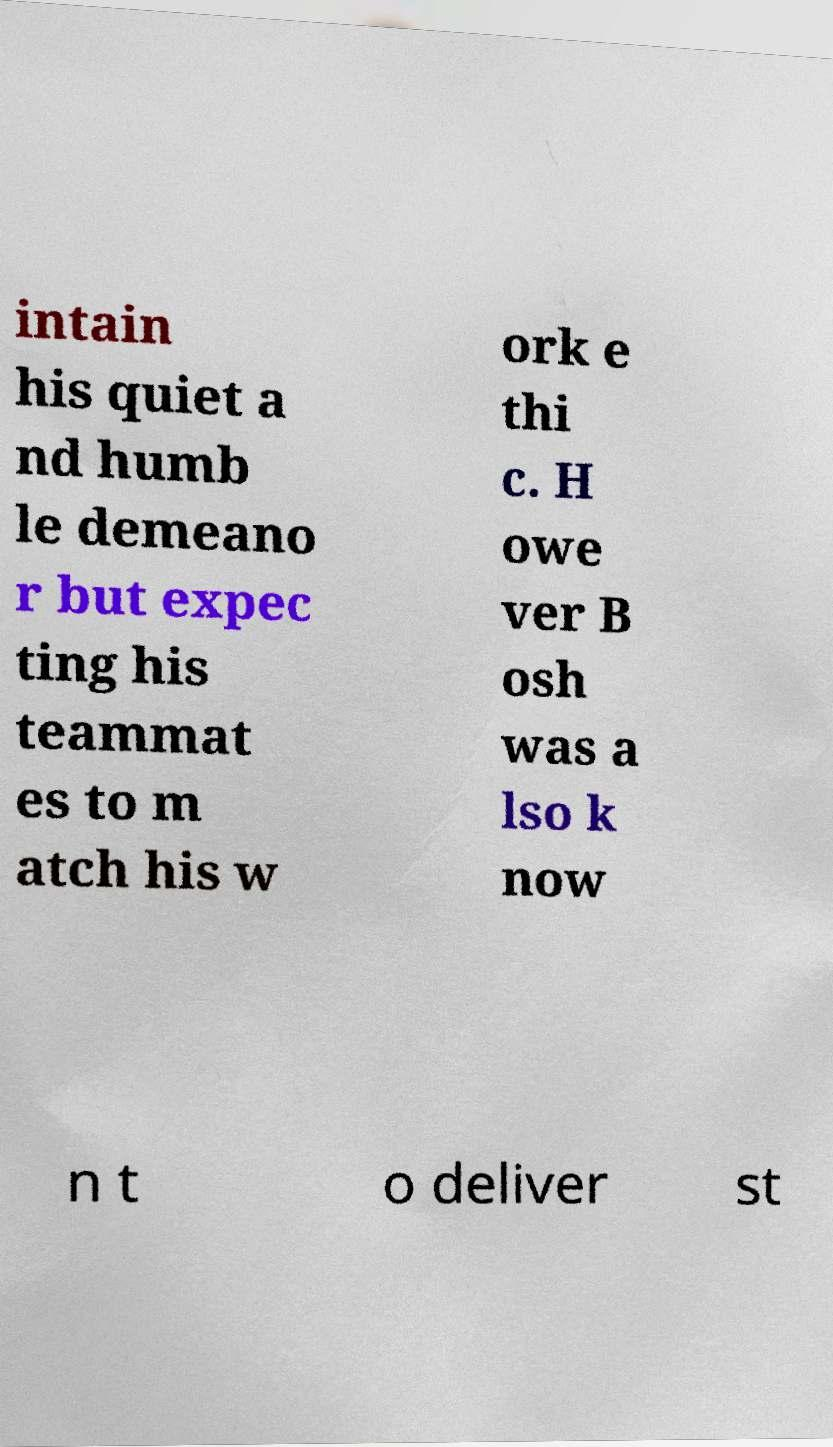What messages or text are displayed in this image? I need them in a readable, typed format. intain his quiet a nd humb le demeano r but expec ting his teammat es to m atch his w ork e thi c. H owe ver B osh was a lso k now n t o deliver st 